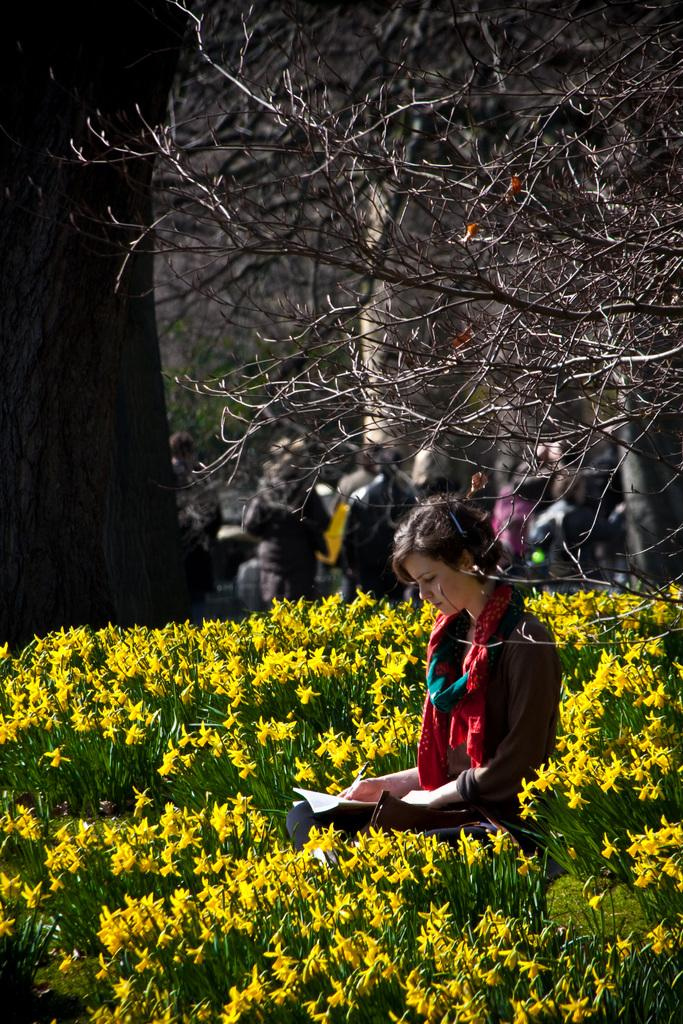What is the woman in the image doing? The woman is sitting in the image. Where is the woman sitting? The woman is sitting among plants. What can be observed about the plants in the image? The plants have flowers. What is the woman holding in the image? The woman is holding a book. What can be seen in the background of the image? There are people and trees in the background of the image. How many heads of lettuce are visible in the image? There are no heads of lettuce present in the image. What type of cats can be seen playing with the woman in the image? There are no cats present in the image. 